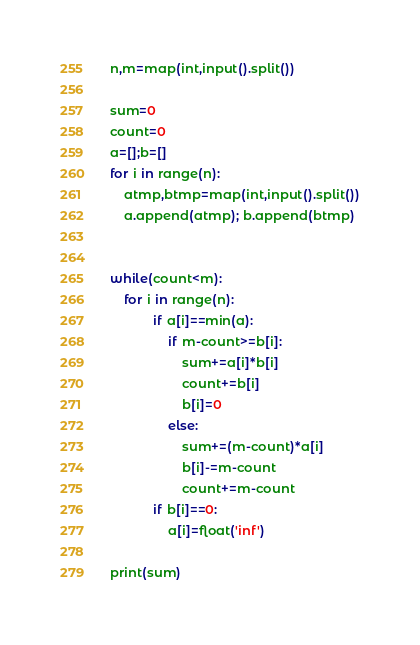Convert code to text. <code><loc_0><loc_0><loc_500><loc_500><_Python_>n,m=map(int,input().split())

sum=0
count=0
a=[];b=[]
for i in range(n):
    atmp,btmp=map(int,input().split())
    a.append(atmp); b.append(btmp)


while(count<m):
    for i in range(n):
            if a[i]==min(a):
                if m-count>=b[i]:
                    sum+=a[i]*b[i]
                    count+=b[i]
                    b[i]=0
                else:
                    sum+=(m-count)*a[i]
                    b[i]-=m-count
                    count+=m-count
            if b[i]==0:
                a[i]=float('inf')

print(sum)</code> 